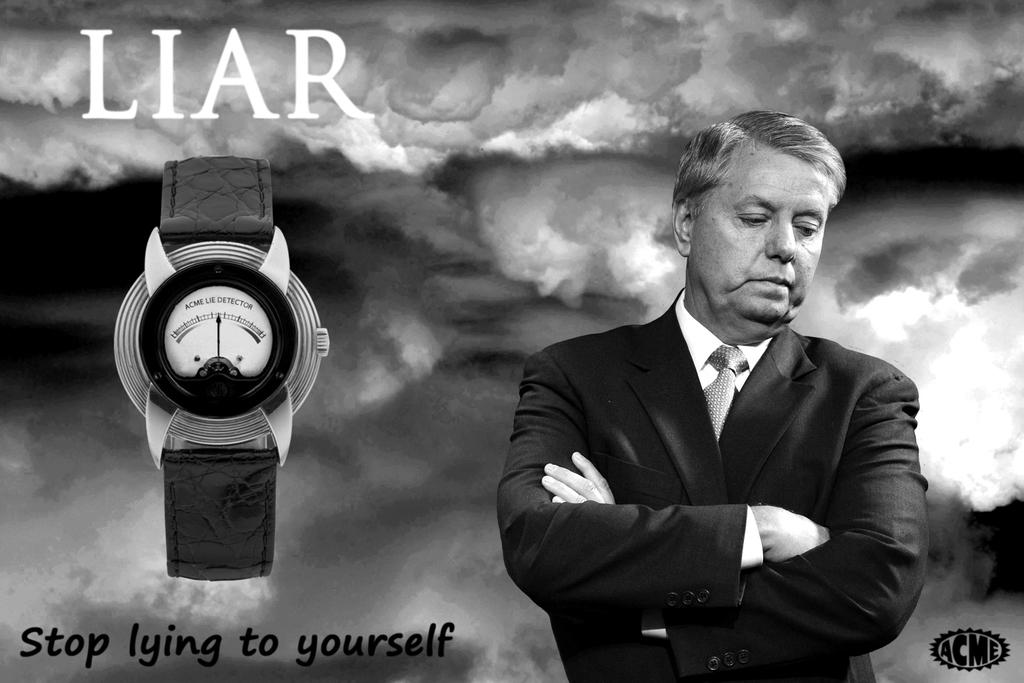<image>
Provide a brief description of the given image. A black and white photograph of a man and the word LIAR 